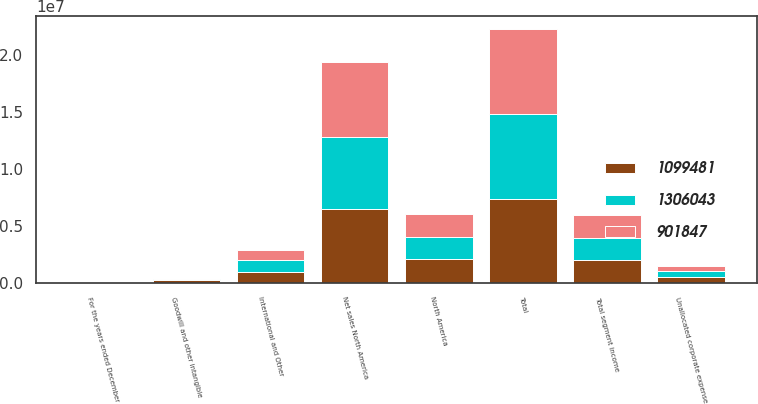Convert chart to OTSL. <chart><loc_0><loc_0><loc_500><loc_500><stacked_bar_chart><ecel><fcel>For the years ended December<fcel>Net sales North America<fcel>International and Other<fcel>Total<fcel>North America<fcel>Total segment income<fcel>Unallocated corporate expense<fcel>Goodwill and other intangible<nl><fcel>901847<fcel>2016<fcel>6.53299e+06<fcel>907193<fcel>7.44018e+06<fcel>2.041e+06<fcel>2.01186e+06<fcel>497423<fcel>4204<nl><fcel>1.09948e+06<fcel>2015<fcel>6.46816e+06<fcel>918468<fcel>7.38663e+06<fcel>2.07397e+06<fcel>1.9759e+06<fcel>497386<fcel>280802<nl><fcel>1.30604e+06<fcel>2014<fcel>6.35273e+06<fcel>1.06904e+06<fcel>7.42177e+06<fcel>1.91621e+06<fcel>1.95621e+06<fcel>503234<fcel>15900<nl></chart> 